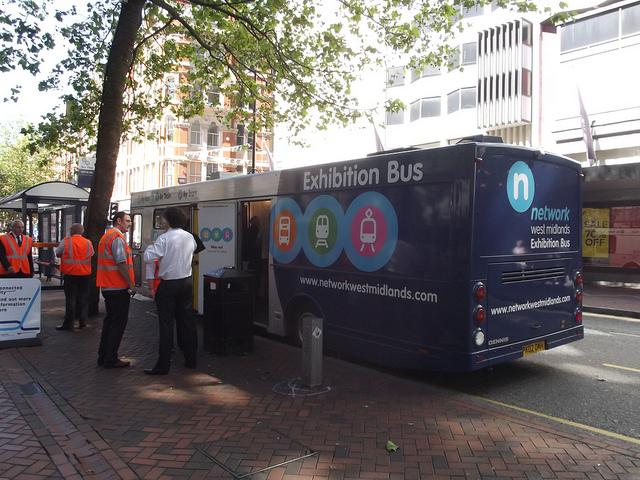What kind of bus is parked in front of the men?

Choices:
A) charter
B) exhibition
C) school
D) tour exhibition 